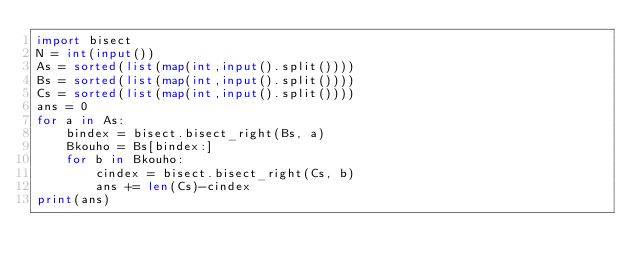<code> <loc_0><loc_0><loc_500><loc_500><_Python_>import bisect
N = int(input())
As = sorted(list(map(int,input().split())))
Bs = sorted(list(map(int,input().split())))
Cs = sorted(list(map(int,input().split())))
ans = 0
for a in As:
    bindex = bisect.bisect_right(Bs, a)
    Bkouho = Bs[bindex:]
    for b in Bkouho:
        cindex = bisect.bisect_right(Cs, b)
        ans += len(Cs)-cindex
print(ans)</code> 